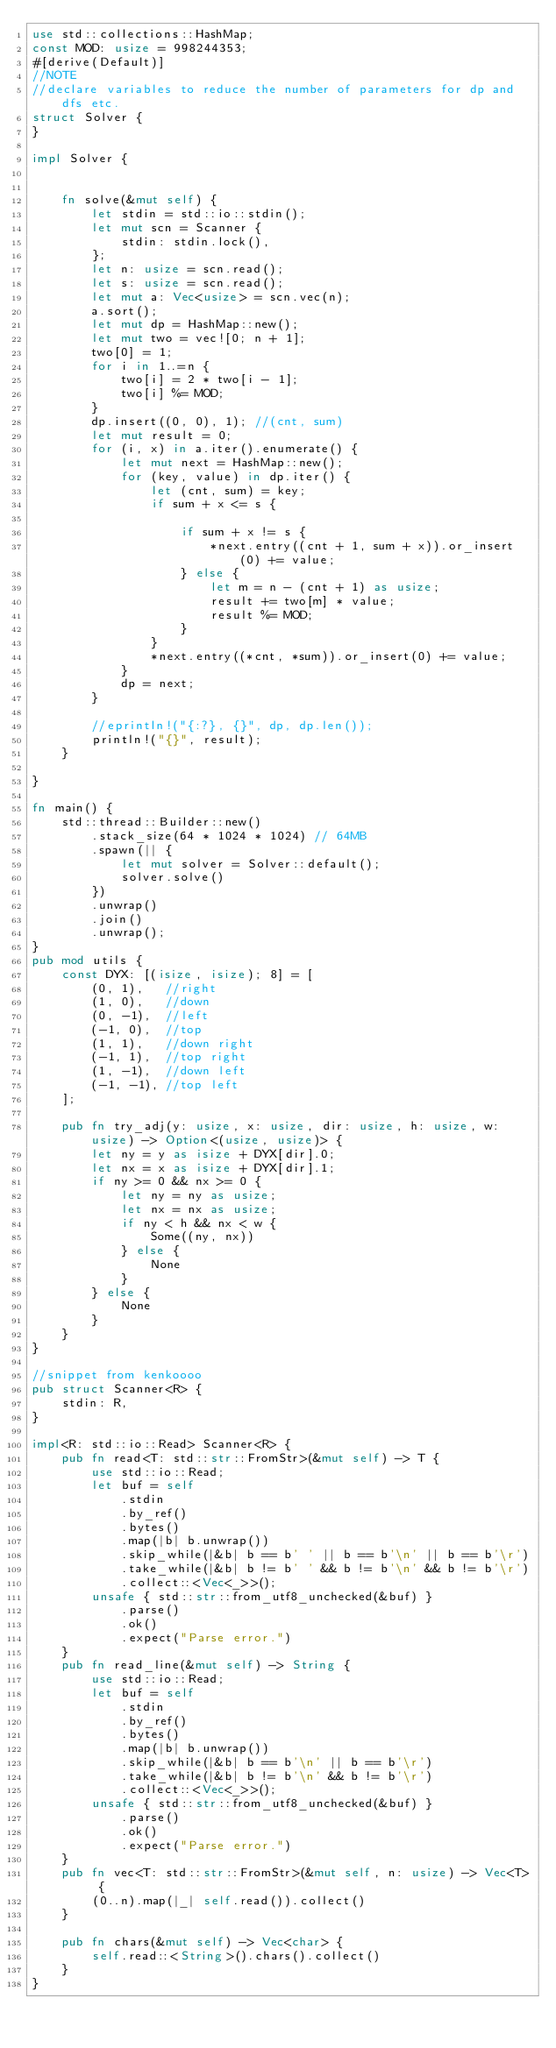Convert code to text. <code><loc_0><loc_0><loc_500><loc_500><_Rust_>use std::collections::HashMap;
const MOD: usize = 998244353;
#[derive(Default)]
//NOTE
//declare variables to reduce the number of parameters for dp and dfs etc.
struct Solver {
}

impl Solver {

    
    fn solve(&mut self) {
        let stdin = std::io::stdin();
        let mut scn = Scanner {
            stdin: stdin.lock(),
        };
        let n: usize = scn.read();
        let s: usize = scn.read();
        let mut a: Vec<usize> = scn.vec(n);
        a.sort();
        let mut dp = HashMap::new();
        let mut two = vec![0; n + 1];
        two[0] = 1;
        for i in 1..=n {
            two[i] = 2 * two[i - 1];
            two[i] %= MOD;
        }
        dp.insert((0, 0), 1); //(cnt, sum)
        let mut result = 0;
        for (i, x) in a.iter().enumerate() {
            let mut next = HashMap::new();
            for (key, value) in dp.iter() {
                let (cnt, sum) = key;
                if sum + x <= s {
                    
                    if sum + x != s {
                        *next.entry((cnt + 1, sum + x)).or_insert(0) += value;
                    } else {
                        let m = n - (cnt + 1) as usize;
                        result += two[m] * value;
                        result %= MOD;
                    }
                }
                *next.entry((*cnt, *sum)).or_insert(0) += value;
            }
            dp = next;
        }
        
        //eprintln!("{:?}, {}", dp, dp.len());
        println!("{}", result);
    }

}

fn main() {
    std::thread::Builder::new()
        .stack_size(64 * 1024 * 1024) // 64MB
        .spawn(|| {
            let mut solver = Solver::default();
            solver.solve()
        })
        .unwrap()
        .join()
        .unwrap();
}
pub mod utils {
    const DYX: [(isize, isize); 8] = [
        (0, 1),   //right
        (1, 0),   //down
        (0, -1),  //left
        (-1, 0),  //top
        (1, 1),   //down right
        (-1, 1),  //top right
        (1, -1),  //down left
        (-1, -1), //top left
    ];

    pub fn try_adj(y: usize, x: usize, dir: usize, h: usize, w: usize) -> Option<(usize, usize)> {
        let ny = y as isize + DYX[dir].0;
        let nx = x as isize + DYX[dir].1;
        if ny >= 0 && nx >= 0 {
            let ny = ny as usize;
            let nx = nx as usize;
            if ny < h && nx < w {
                Some((ny, nx))
            } else {
                None
            }
        } else {
            None
        }
    }
}

//snippet from kenkoooo
pub struct Scanner<R> {
    stdin: R,
}

impl<R: std::io::Read> Scanner<R> {
    pub fn read<T: std::str::FromStr>(&mut self) -> T {
        use std::io::Read;
        let buf = self
            .stdin
            .by_ref()
            .bytes()
            .map(|b| b.unwrap())
            .skip_while(|&b| b == b' ' || b == b'\n' || b == b'\r')
            .take_while(|&b| b != b' ' && b != b'\n' && b != b'\r')
            .collect::<Vec<_>>();
        unsafe { std::str::from_utf8_unchecked(&buf) }
            .parse()
            .ok()
            .expect("Parse error.")
    }
    pub fn read_line(&mut self) -> String {
        use std::io::Read;
        let buf = self
            .stdin
            .by_ref()
            .bytes()
            .map(|b| b.unwrap())
            .skip_while(|&b| b == b'\n' || b == b'\r')
            .take_while(|&b| b != b'\n' && b != b'\r')
            .collect::<Vec<_>>();
        unsafe { std::str::from_utf8_unchecked(&buf) }
            .parse()
            .ok()
            .expect("Parse error.")
    }
    pub fn vec<T: std::str::FromStr>(&mut self, n: usize) -> Vec<T> {
        (0..n).map(|_| self.read()).collect()
    }

    pub fn chars(&mut self) -> Vec<char> {
        self.read::<String>().chars().collect()
    }
}
</code> 